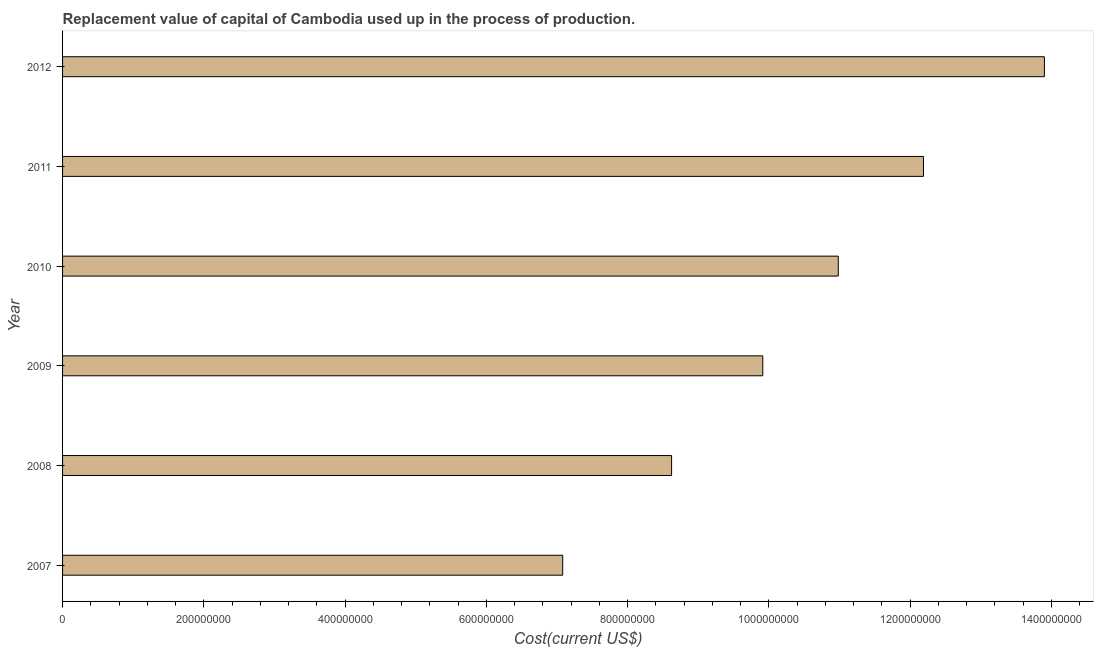Does the graph contain any zero values?
Ensure brevity in your answer.  No. What is the title of the graph?
Make the answer very short. Replacement value of capital of Cambodia used up in the process of production. What is the label or title of the X-axis?
Provide a short and direct response. Cost(current US$). What is the label or title of the Y-axis?
Provide a succinct answer. Year. What is the consumption of fixed capital in 2011?
Ensure brevity in your answer.  1.22e+09. Across all years, what is the maximum consumption of fixed capital?
Provide a succinct answer. 1.39e+09. Across all years, what is the minimum consumption of fixed capital?
Keep it short and to the point. 7.08e+08. What is the sum of the consumption of fixed capital?
Make the answer very short. 6.27e+09. What is the difference between the consumption of fixed capital in 2008 and 2009?
Ensure brevity in your answer.  -1.29e+08. What is the average consumption of fixed capital per year?
Make the answer very short. 1.04e+09. What is the median consumption of fixed capital?
Your response must be concise. 1.04e+09. What is the ratio of the consumption of fixed capital in 2008 to that in 2010?
Your answer should be very brief. 0.79. Is the consumption of fixed capital in 2010 less than that in 2011?
Your response must be concise. Yes. Is the difference between the consumption of fixed capital in 2010 and 2011 greater than the difference between any two years?
Provide a short and direct response. No. What is the difference between the highest and the second highest consumption of fixed capital?
Ensure brevity in your answer.  1.71e+08. Is the sum of the consumption of fixed capital in 2008 and 2011 greater than the maximum consumption of fixed capital across all years?
Keep it short and to the point. Yes. What is the difference between the highest and the lowest consumption of fixed capital?
Keep it short and to the point. 6.82e+08. How many bars are there?
Make the answer very short. 6. Are all the bars in the graph horizontal?
Provide a succinct answer. Yes. How many years are there in the graph?
Your answer should be very brief. 6. What is the difference between two consecutive major ticks on the X-axis?
Make the answer very short. 2.00e+08. Are the values on the major ticks of X-axis written in scientific E-notation?
Provide a short and direct response. No. What is the Cost(current US$) of 2007?
Make the answer very short. 7.08e+08. What is the Cost(current US$) in 2008?
Your answer should be very brief. 8.62e+08. What is the Cost(current US$) of 2009?
Offer a very short reply. 9.91e+08. What is the Cost(current US$) in 2010?
Keep it short and to the point. 1.10e+09. What is the Cost(current US$) in 2011?
Keep it short and to the point. 1.22e+09. What is the Cost(current US$) of 2012?
Your response must be concise. 1.39e+09. What is the difference between the Cost(current US$) in 2007 and 2008?
Your response must be concise. -1.54e+08. What is the difference between the Cost(current US$) in 2007 and 2009?
Your response must be concise. -2.83e+08. What is the difference between the Cost(current US$) in 2007 and 2010?
Offer a very short reply. -3.90e+08. What is the difference between the Cost(current US$) in 2007 and 2011?
Offer a terse response. -5.11e+08. What is the difference between the Cost(current US$) in 2007 and 2012?
Make the answer very short. -6.82e+08. What is the difference between the Cost(current US$) in 2008 and 2009?
Offer a very short reply. -1.29e+08. What is the difference between the Cost(current US$) in 2008 and 2010?
Your answer should be very brief. -2.36e+08. What is the difference between the Cost(current US$) in 2008 and 2011?
Offer a very short reply. -3.57e+08. What is the difference between the Cost(current US$) in 2008 and 2012?
Offer a terse response. -5.28e+08. What is the difference between the Cost(current US$) in 2009 and 2010?
Give a very brief answer. -1.07e+08. What is the difference between the Cost(current US$) in 2009 and 2011?
Give a very brief answer. -2.27e+08. What is the difference between the Cost(current US$) in 2009 and 2012?
Provide a succinct answer. -3.99e+08. What is the difference between the Cost(current US$) in 2010 and 2011?
Your response must be concise. -1.21e+08. What is the difference between the Cost(current US$) in 2010 and 2012?
Your response must be concise. -2.92e+08. What is the difference between the Cost(current US$) in 2011 and 2012?
Offer a very short reply. -1.71e+08. What is the ratio of the Cost(current US$) in 2007 to that in 2008?
Offer a very short reply. 0.82. What is the ratio of the Cost(current US$) in 2007 to that in 2009?
Offer a very short reply. 0.71. What is the ratio of the Cost(current US$) in 2007 to that in 2010?
Give a very brief answer. 0.65. What is the ratio of the Cost(current US$) in 2007 to that in 2011?
Make the answer very short. 0.58. What is the ratio of the Cost(current US$) in 2007 to that in 2012?
Give a very brief answer. 0.51. What is the ratio of the Cost(current US$) in 2008 to that in 2009?
Your answer should be very brief. 0.87. What is the ratio of the Cost(current US$) in 2008 to that in 2010?
Offer a very short reply. 0.79. What is the ratio of the Cost(current US$) in 2008 to that in 2011?
Your answer should be compact. 0.71. What is the ratio of the Cost(current US$) in 2008 to that in 2012?
Give a very brief answer. 0.62. What is the ratio of the Cost(current US$) in 2009 to that in 2010?
Your response must be concise. 0.9. What is the ratio of the Cost(current US$) in 2009 to that in 2011?
Make the answer very short. 0.81. What is the ratio of the Cost(current US$) in 2009 to that in 2012?
Offer a very short reply. 0.71. What is the ratio of the Cost(current US$) in 2010 to that in 2011?
Keep it short and to the point. 0.9. What is the ratio of the Cost(current US$) in 2010 to that in 2012?
Your answer should be very brief. 0.79. What is the ratio of the Cost(current US$) in 2011 to that in 2012?
Your answer should be very brief. 0.88. 